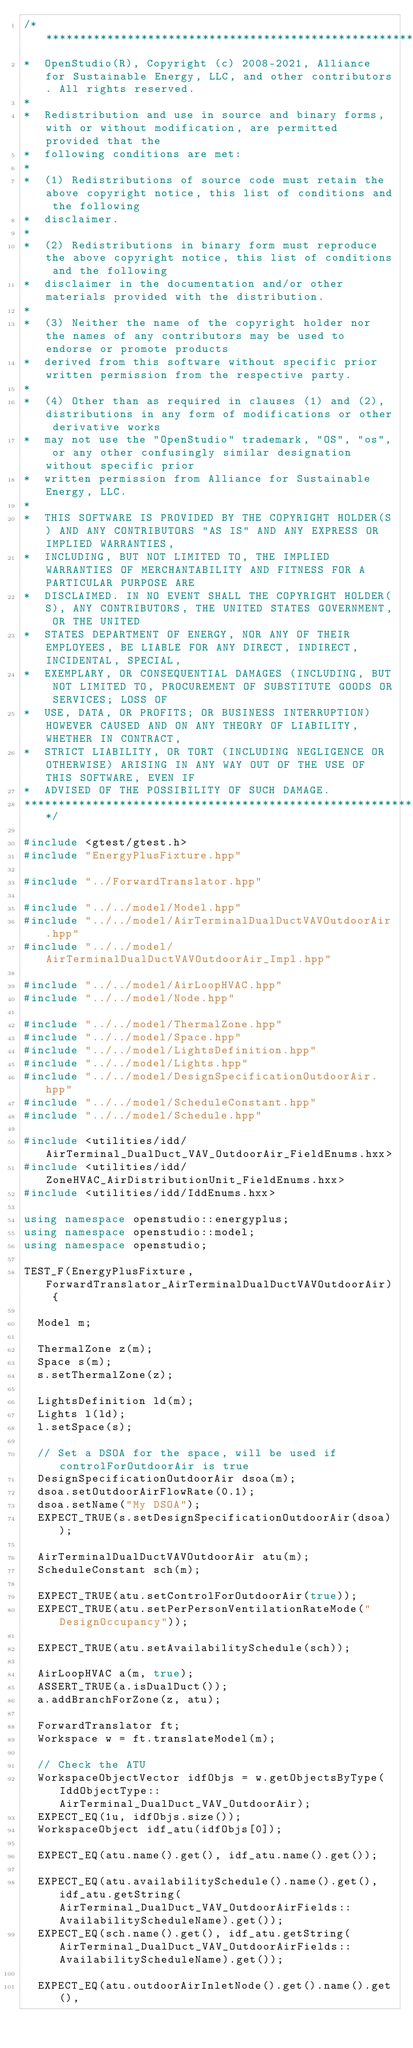Convert code to text. <code><loc_0><loc_0><loc_500><loc_500><_C++_>/***********************************************************************************************************************
*  OpenStudio(R), Copyright (c) 2008-2021, Alliance for Sustainable Energy, LLC, and other contributors. All rights reserved.
*
*  Redistribution and use in source and binary forms, with or without modification, are permitted provided that the
*  following conditions are met:
*
*  (1) Redistributions of source code must retain the above copyright notice, this list of conditions and the following
*  disclaimer.
*
*  (2) Redistributions in binary form must reproduce the above copyright notice, this list of conditions and the following
*  disclaimer in the documentation and/or other materials provided with the distribution.
*
*  (3) Neither the name of the copyright holder nor the names of any contributors may be used to endorse or promote products
*  derived from this software without specific prior written permission from the respective party.
*
*  (4) Other than as required in clauses (1) and (2), distributions in any form of modifications or other derivative works
*  may not use the "OpenStudio" trademark, "OS", "os", or any other confusingly similar designation without specific prior
*  written permission from Alliance for Sustainable Energy, LLC.
*
*  THIS SOFTWARE IS PROVIDED BY THE COPYRIGHT HOLDER(S) AND ANY CONTRIBUTORS "AS IS" AND ANY EXPRESS OR IMPLIED WARRANTIES,
*  INCLUDING, BUT NOT LIMITED TO, THE IMPLIED WARRANTIES OF MERCHANTABILITY AND FITNESS FOR A PARTICULAR PURPOSE ARE
*  DISCLAIMED. IN NO EVENT SHALL THE COPYRIGHT HOLDER(S), ANY CONTRIBUTORS, THE UNITED STATES GOVERNMENT, OR THE UNITED
*  STATES DEPARTMENT OF ENERGY, NOR ANY OF THEIR EMPLOYEES, BE LIABLE FOR ANY DIRECT, INDIRECT, INCIDENTAL, SPECIAL,
*  EXEMPLARY, OR CONSEQUENTIAL DAMAGES (INCLUDING, BUT NOT LIMITED TO, PROCUREMENT OF SUBSTITUTE GOODS OR SERVICES; LOSS OF
*  USE, DATA, OR PROFITS; OR BUSINESS INTERRUPTION) HOWEVER CAUSED AND ON ANY THEORY OF LIABILITY, WHETHER IN CONTRACT,
*  STRICT LIABILITY, OR TORT (INCLUDING NEGLIGENCE OR OTHERWISE) ARISING IN ANY WAY OUT OF THE USE OF THIS SOFTWARE, EVEN IF
*  ADVISED OF THE POSSIBILITY OF SUCH DAMAGE.
***********************************************************************************************************************/

#include <gtest/gtest.h>
#include "EnergyPlusFixture.hpp"

#include "../ForwardTranslator.hpp"

#include "../../model/Model.hpp"
#include "../../model/AirTerminalDualDuctVAVOutdoorAir.hpp"
#include "../../model/AirTerminalDualDuctVAVOutdoorAir_Impl.hpp"

#include "../../model/AirLoopHVAC.hpp"
#include "../../model/Node.hpp"

#include "../../model/ThermalZone.hpp"
#include "../../model/Space.hpp"
#include "../../model/LightsDefinition.hpp"
#include "../../model/Lights.hpp"
#include "../../model/DesignSpecificationOutdoorAir.hpp"
#include "../../model/ScheduleConstant.hpp"
#include "../../model/Schedule.hpp"

#include <utilities/idd/AirTerminal_DualDuct_VAV_OutdoorAir_FieldEnums.hxx>
#include <utilities/idd/ZoneHVAC_AirDistributionUnit_FieldEnums.hxx>
#include <utilities/idd/IddEnums.hxx>

using namespace openstudio::energyplus;
using namespace openstudio::model;
using namespace openstudio;

TEST_F(EnergyPlusFixture, ForwardTranslator_AirTerminalDualDuctVAVOutdoorAir) {

  Model m;

  ThermalZone z(m);
  Space s(m);
  s.setThermalZone(z);

  LightsDefinition ld(m);
  Lights l(ld);
  l.setSpace(s);

  // Set a DSOA for the space, will be used if controlForOutdoorAir is true
  DesignSpecificationOutdoorAir dsoa(m);
  dsoa.setOutdoorAirFlowRate(0.1);
  dsoa.setName("My DSOA");
  EXPECT_TRUE(s.setDesignSpecificationOutdoorAir(dsoa));

  AirTerminalDualDuctVAVOutdoorAir atu(m);
  ScheduleConstant sch(m);

  EXPECT_TRUE(atu.setControlForOutdoorAir(true));
  EXPECT_TRUE(atu.setPerPersonVentilationRateMode("DesignOccupancy"));

  EXPECT_TRUE(atu.setAvailabilitySchedule(sch));

  AirLoopHVAC a(m, true);
  ASSERT_TRUE(a.isDualDuct());
  a.addBranchForZone(z, atu);

  ForwardTranslator ft;
  Workspace w = ft.translateModel(m);

  // Check the ATU
  WorkspaceObjectVector idfObjs = w.getObjectsByType(IddObjectType::AirTerminal_DualDuct_VAV_OutdoorAir);
  EXPECT_EQ(1u, idfObjs.size());
  WorkspaceObject idf_atu(idfObjs[0]);

  EXPECT_EQ(atu.name().get(), idf_atu.name().get());

  EXPECT_EQ(atu.availabilitySchedule().name().get(), idf_atu.getString(AirTerminal_DualDuct_VAV_OutdoorAirFields::AvailabilityScheduleName).get());
  EXPECT_EQ(sch.name().get(), idf_atu.getString(AirTerminal_DualDuct_VAV_OutdoorAirFields::AvailabilityScheduleName).get());

  EXPECT_EQ(atu.outdoorAirInletNode().get().name().get(),</code> 